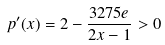Convert formula to latex. <formula><loc_0><loc_0><loc_500><loc_500>p ^ { \prime } ( x ) = 2 - \frac { 3 2 7 5 e } { 2 x - 1 } > 0</formula> 